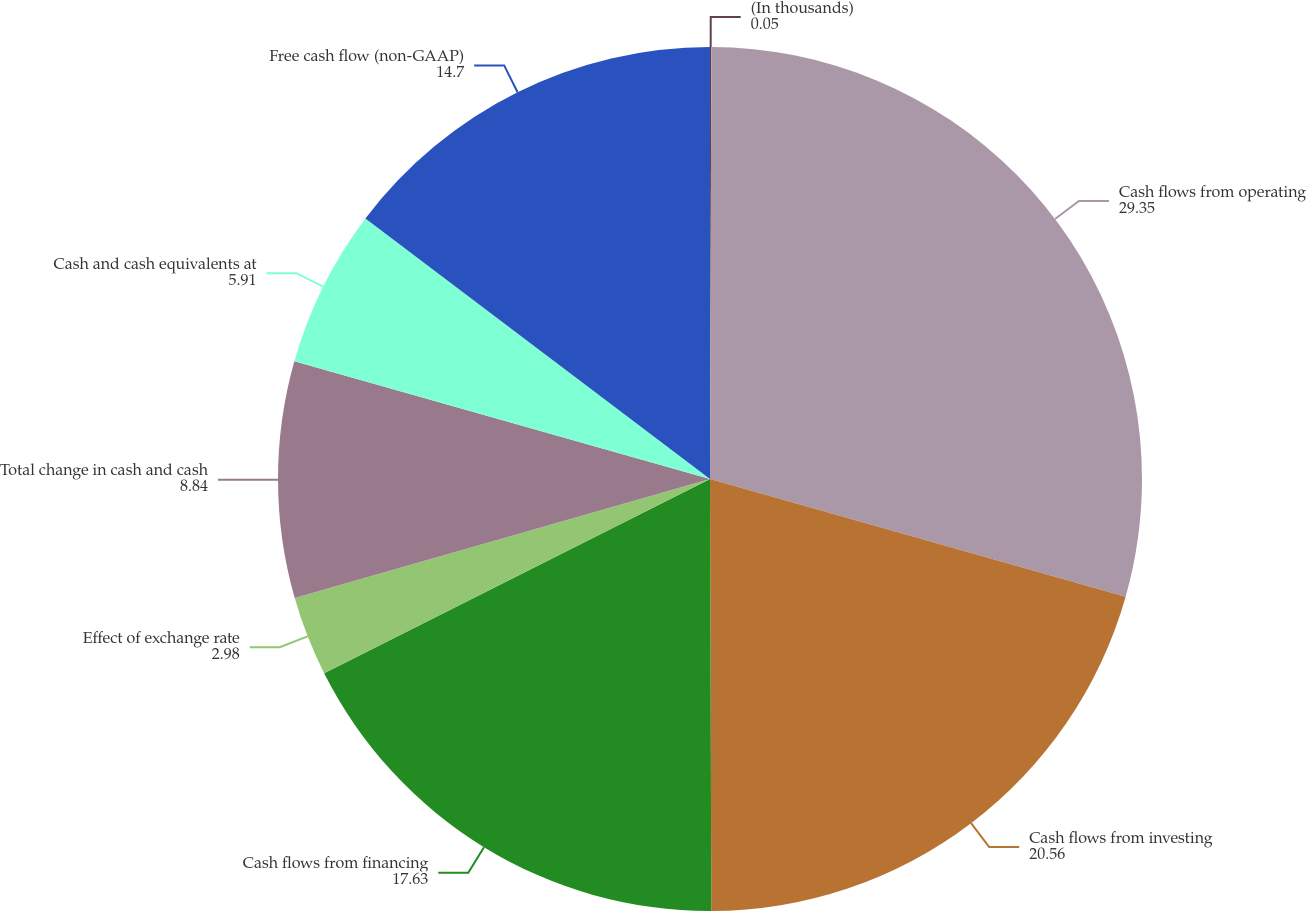Convert chart. <chart><loc_0><loc_0><loc_500><loc_500><pie_chart><fcel>(In thousands)<fcel>Cash flows from operating<fcel>Cash flows from investing<fcel>Cash flows from financing<fcel>Effect of exchange rate<fcel>Total change in cash and cash<fcel>Cash and cash equivalents at<fcel>Free cash flow (non-GAAP)<nl><fcel>0.05%<fcel>29.35%<fcel>20.56%<fcel>17.63%<fcel>2.98%<fcel>8.84%<fcel>5.91%<fcel>14.7%<nl></chart> 